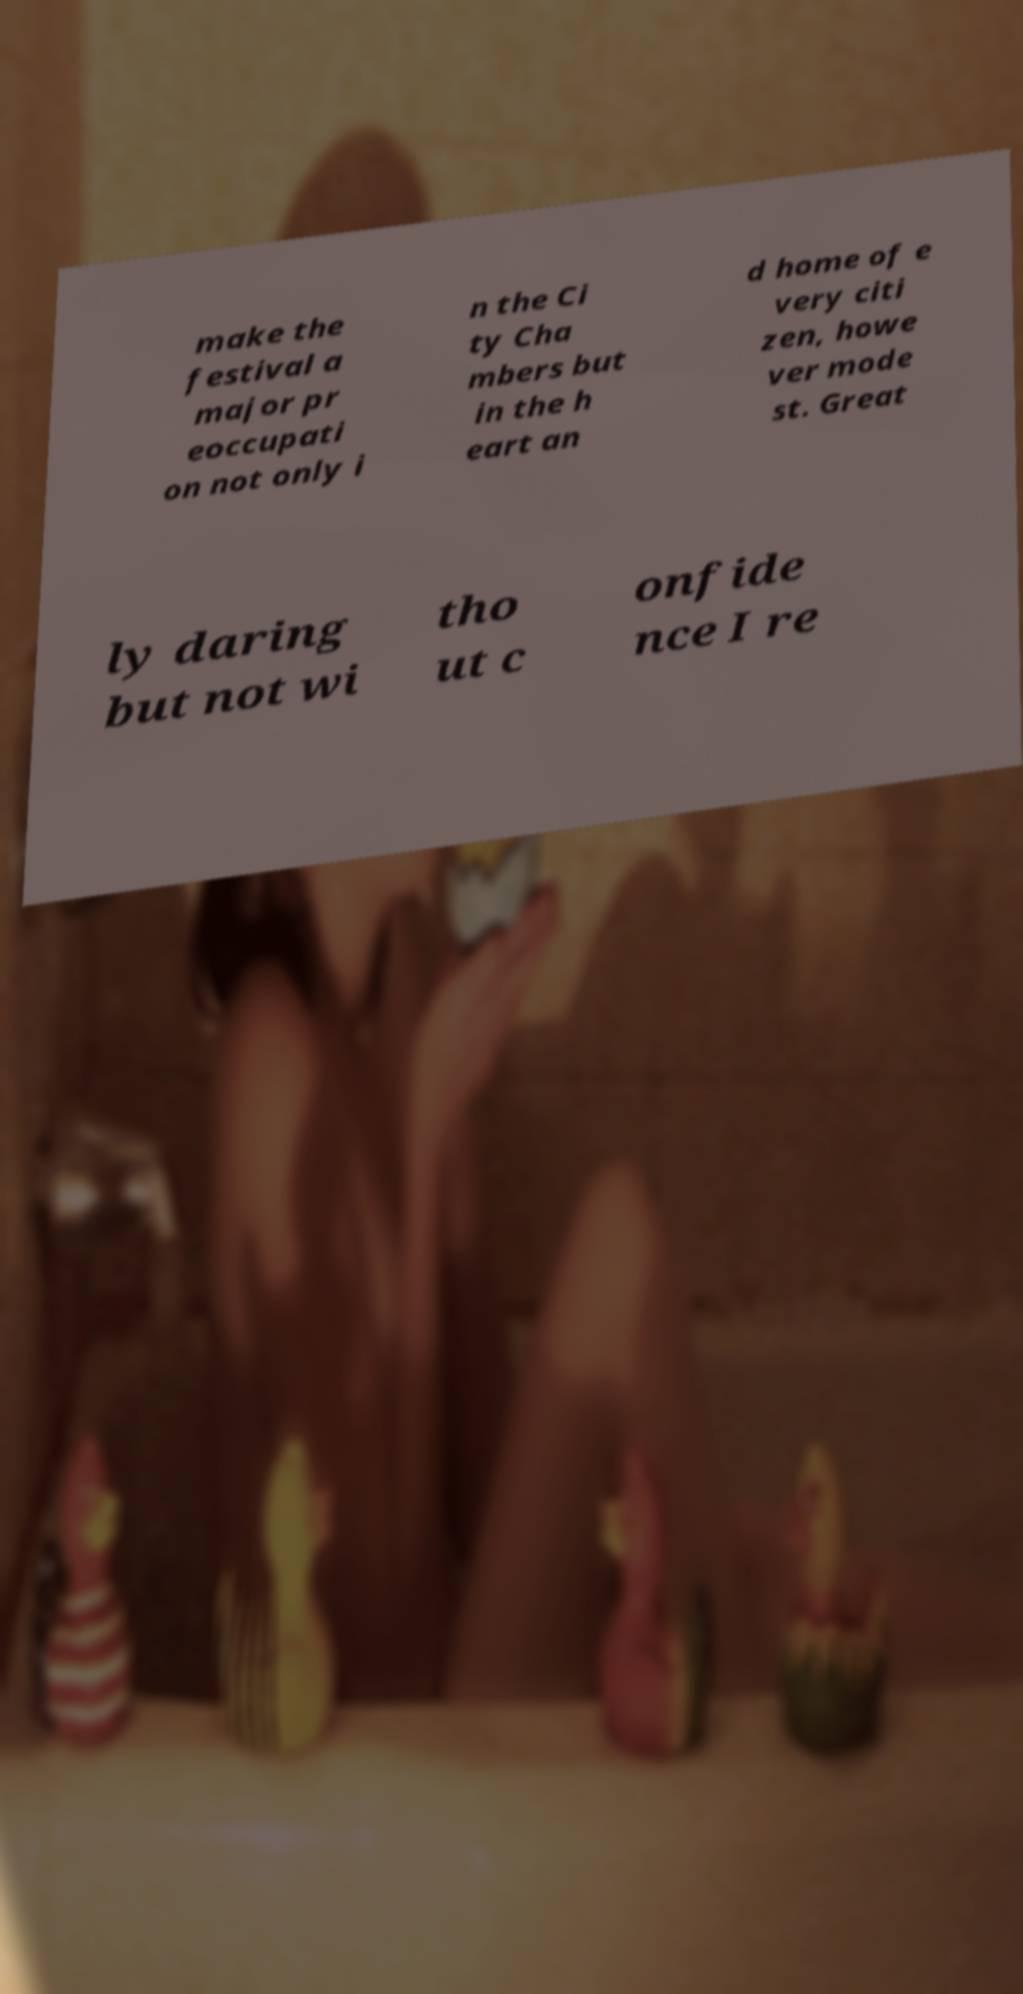For documentation purposes, I need the text within this image transcribed. Could you provide that? make the festival a major pr eoccupati on not only i n the Ci ty Cha mbers but in the h eart an d home of e very citi zen, howe ver mode st. Great ly daring but not wi tho ut c onfide nce I re 